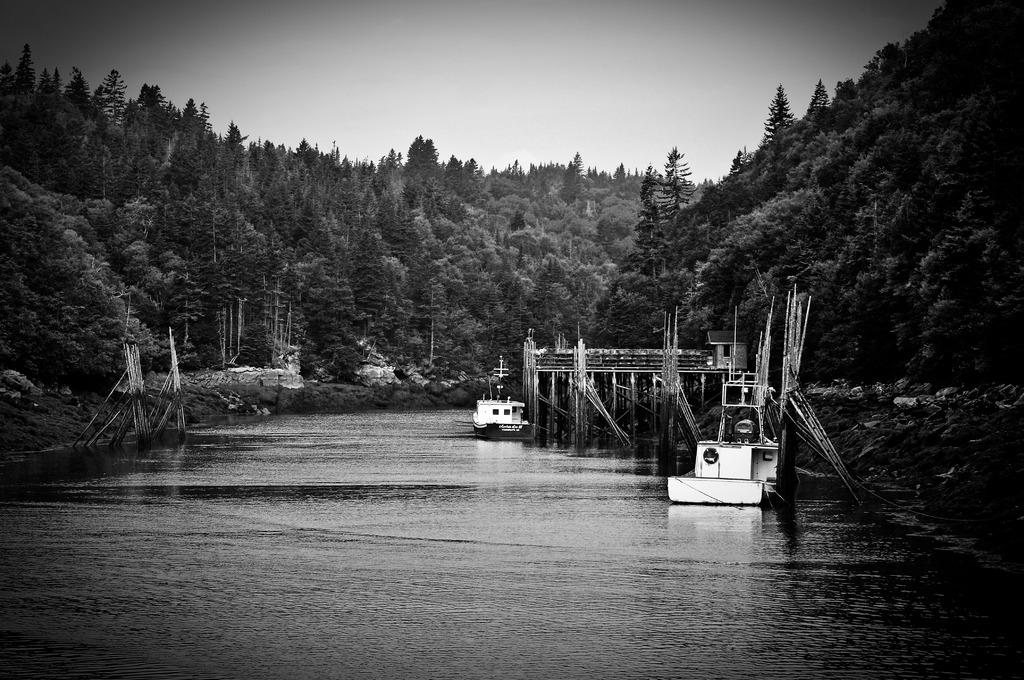What is the color scheme of the image? The image is black and white. What can be seen at the bottom of the image? There is a surface of water at the bottom of the image. What type of vegetation is visible in the background of the image? There are trees in the background of the image. What is visible at the top of the image? The sky is visible at the top of the image. Can you see an umbrella in the image? No, there is no umbrella present in the image. What type of salt is being used to season the water in the image? There is no salt or seasoning present in the image; it is a surface of water. 